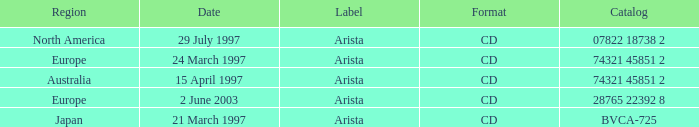What's the Date for the Region of Europe and has the Catalog of 28765 22392 8? 2 June 2003. 